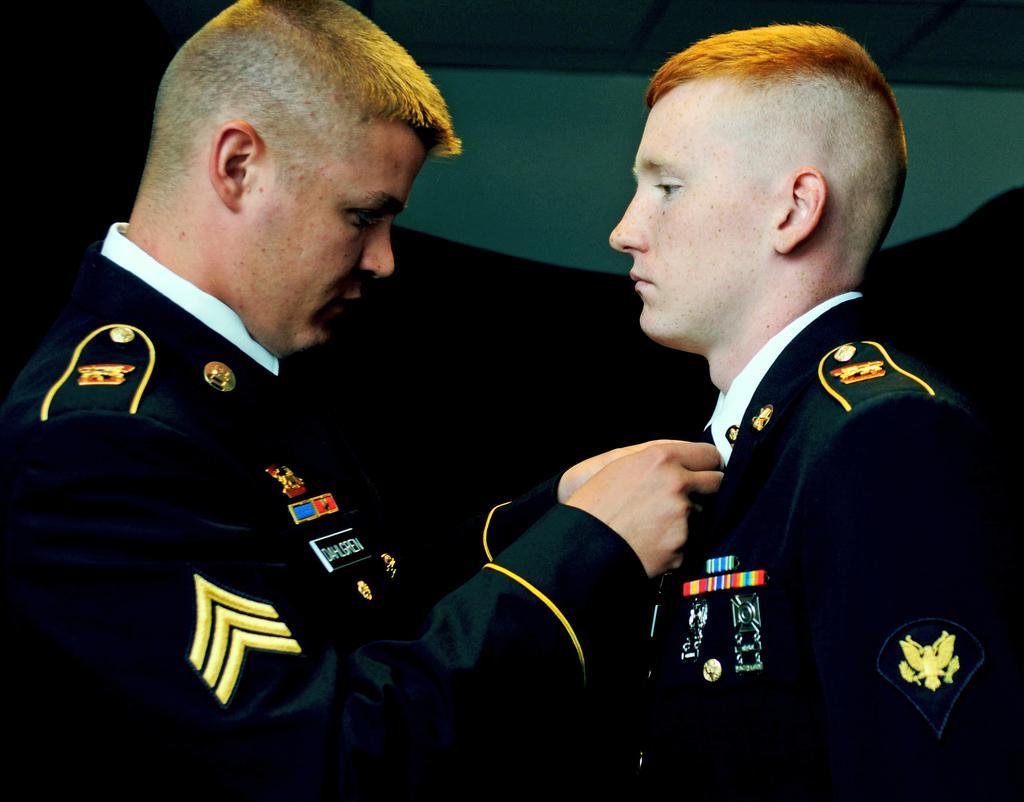Could you give a brief overview of what you see in this image? This picture shows couple of men Standing and we see a man holding a tie of another man, Both of them wore coats and we see badges and a white wall. 